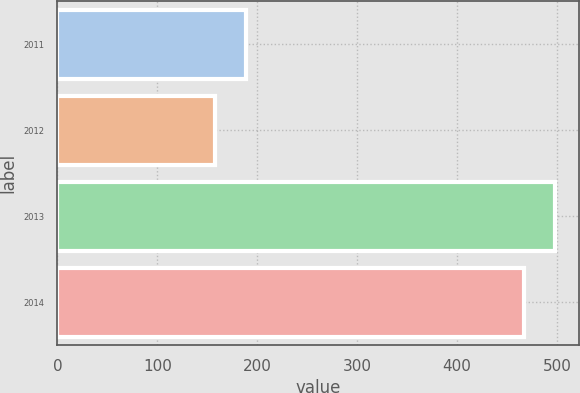Convert chart. <chart><loc_0><loc_0><loc_500><loc_500><bar_chart><fcel>2011<fcel>2012<fcel>2013<fcel>2014<nl><fcel>188.79<fcel>157.8<fcel>497.49<fcel>466.5<nl></chart> 